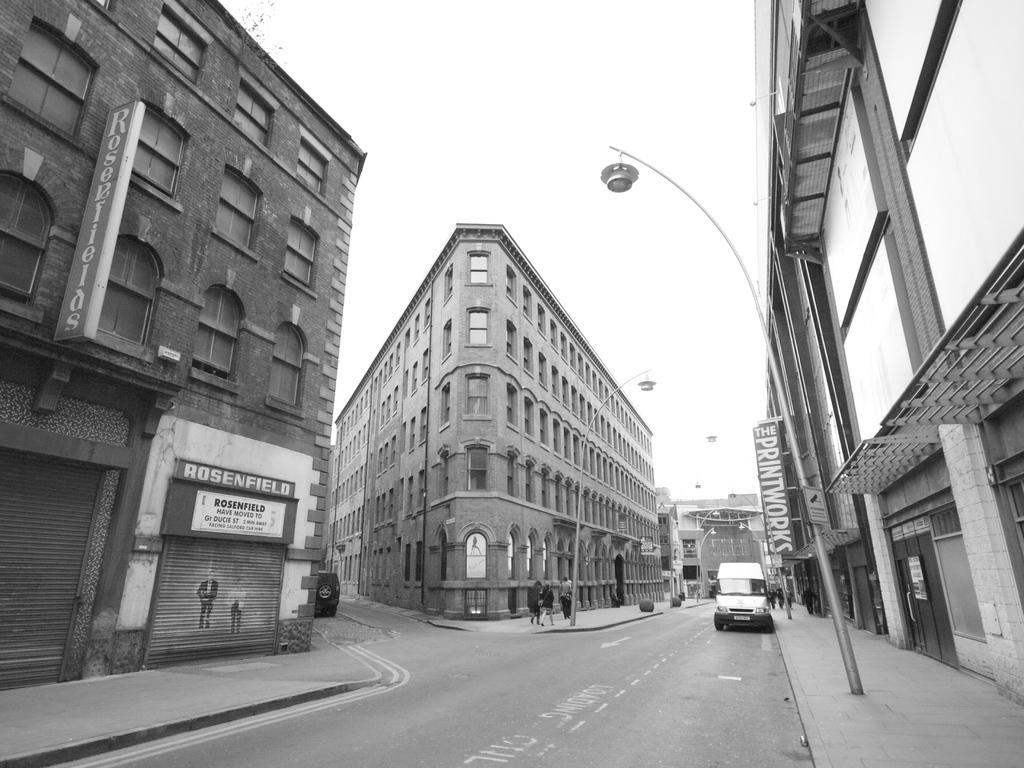What does the sign on the right side of the street advertise?
Offer a very short reply. Printworks. What store front is on the left?
Provide a short and direct response. Rosenfield. 